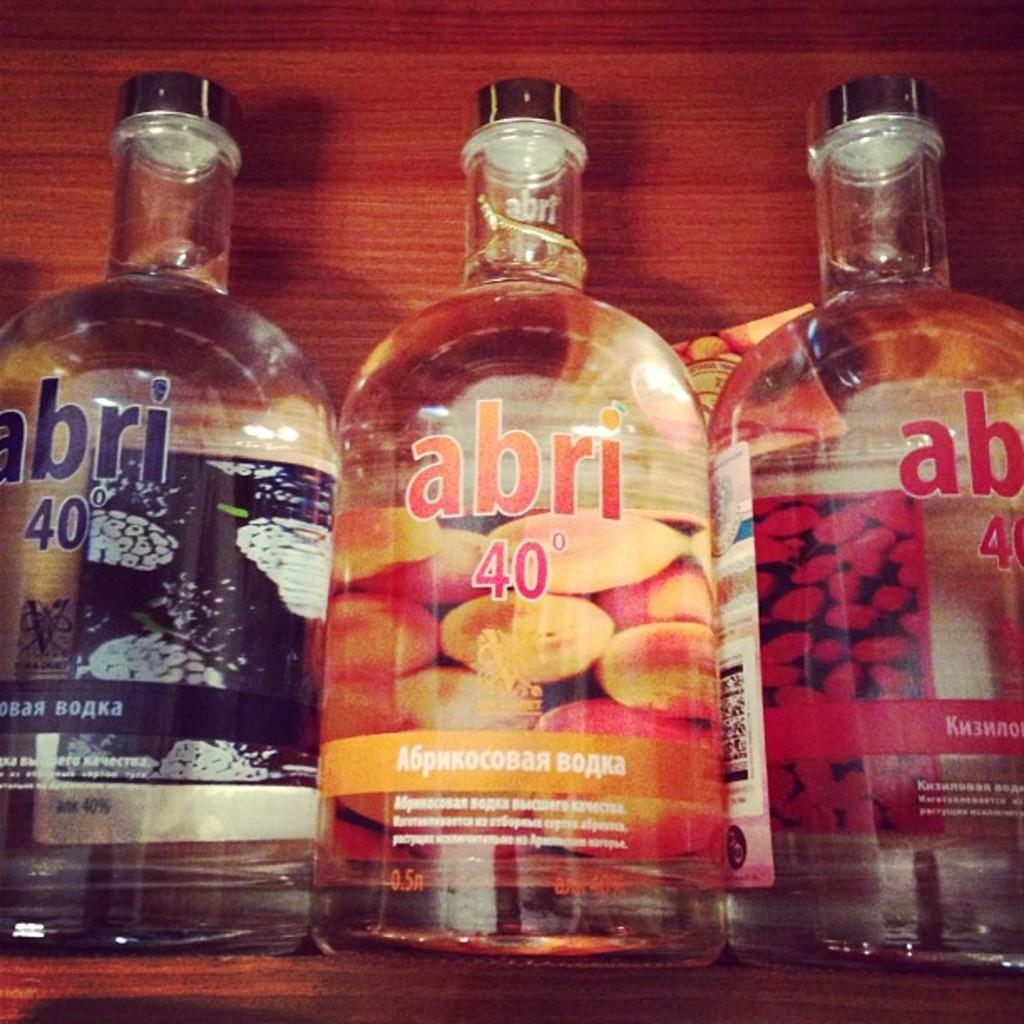<image>
Relay a brief, clear account of the picture shown. A blue, orange and red abri bottles sit on a wood shelf. 